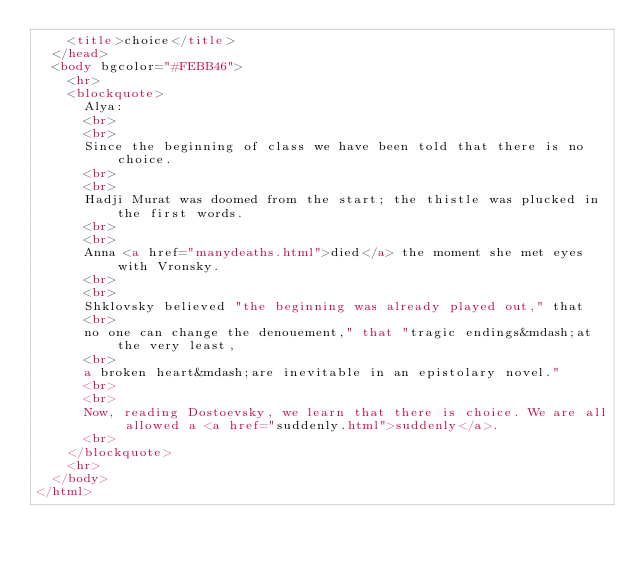Convert code to text. <code><loc_0><loc_0><loc_500><loc_500><_HTML_>    <title>choice</title>
  </head>
  <body bgcolor="#FEBB46">
    <hr>
    <blockquote>
      Alya:
      <br>
      <br>
      Since the beginning of class we have been told that there is no choice.
      <br>
      <br>
      Hadji Murat was doomed from the start; the thistle was plucked in the first words.
      <br>
      <br>
      Anna <a href="manydeaths.html">died</a> the moment she met eyes with Vronsky.
      <br>
      <br>
      Shklovsky believed "the beginning was already played out," that
      <br>
      no one can change the denouement," that "tragic endings&mdash;at the very least,
      <br>
      a broken heart&mdash;are inevitable in an epistolary novel."
      <br>
      <br>
      Now, reading Dostoevsky, we learn that there is choice. We are all allowed a <a href="suddenly.html">suddenly</a>.
      <br>
    </blockquote>
    <hr>
  </body>
</html>
</code> 